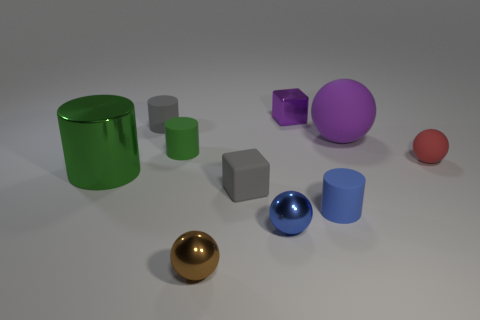What is the shape of the red thing?
Make the answer very short. Sphere. There is a object that is the same color as the big shiny cylinder; what size is it?
Your response must be concise. Small. There is a purple ball on the right side of the small gray rubber object that is in front of the tiny gray cylinder; what size is it?
Your answer should be compact. Large. There is a shiny thing left of the small brown metallic ball; how big is it?
Your answer should be very brief. Large. Is the number of big purple spheres left of the red rubber object less than the number of small rubber objects on the right side of the gray cube?
Provide a succinct answer. Yes. The tiny rubber ball is what color?
Your answer should be very brief. Red. Is there a small thing of the same color as the metallic cylinder?
Your response must be concise. Yes. There is a gray rubber thing that is in front of the red object right of the cube behind the red rubber ball; what shape is it?
Give a very brief answer. Cube. There is a object that is on the right side of the large matte thing; what is its material?
Make the answer very short. Rubber. There is a blue object left of the tiny shiny object that is behind the blue object to the right of the small purple shiny thing; what size is it?
Make the answer very short. Small. 